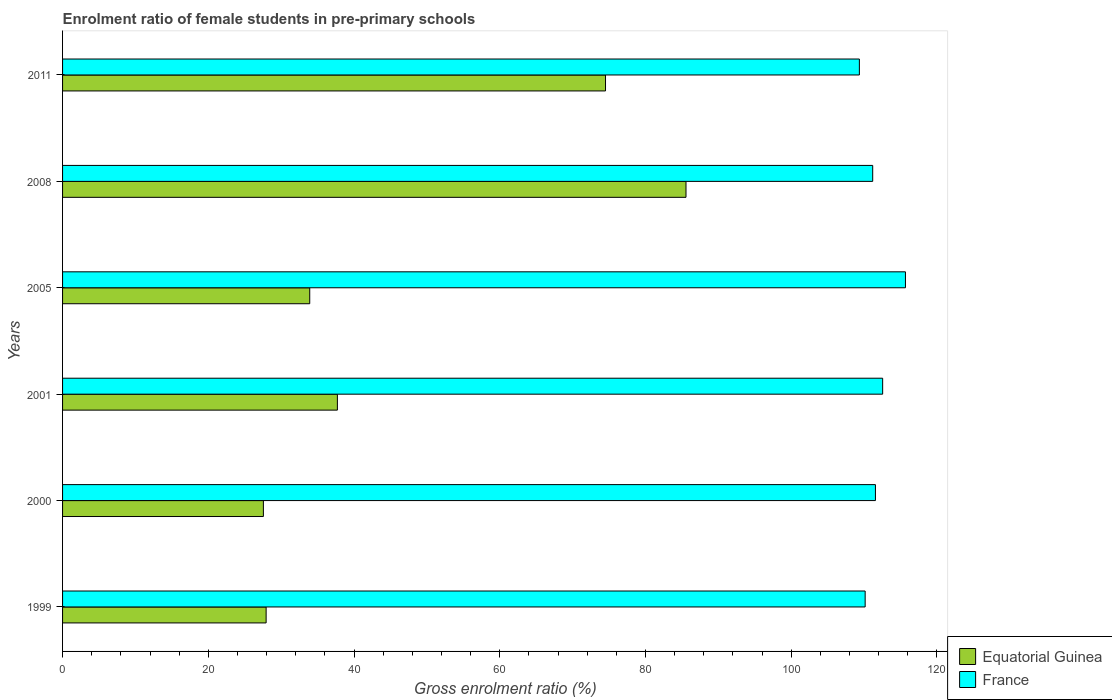Are the number of bars on each tick of the Y-axis equal?
Your answer should be very brief. Yes. How many bars are there on the 6th tick from the bottom?
Provide a succinct answer. 2. What is the label of the 2nd group of bars from the top?
Offer a very short reply. 2008. In how many cases, is the number of bars for a given year not equal to the number of legend labels?
Your answer should be very brief. 0. What is the enrolment ratio of female students in pre-primary schools in France in 2008?
Make the answer very short. 111.18. Across all years, what is the maximum enrolment ratio of female students in pre-primary schools in France?
Provide a succinct answer. 115.68. Across all years, what is the minimum enrolment ratio of female students in pre-primary schools in France?
Your answer should be very brief. 109.35. In which year was the enrolment ratio of female students in pre-primary schools in France maximum?
Provide a succinct answer. 2005. What is the total enrolment ratio of female students in pre-primary schools in Equatorial Guinea in the graph?
Your answer should be very brief. 287.21. What is the difference between the enrolment ratio of female students in pre-primary schools in Equatorial Guinea in 2000 and that in 2001?
Provide a short and direct response. -10.16. What is the difference between the enrolment ratio of female students in pre-primary schools in Equatorial Guinea in 2000 and the enrolment ratio of female students in pre-primary schools in France in 1999?
Give a very brief answer. -82.59. What is the average enrolment ratio of female students in pre-primary schools in Equatorial Guinea per year?
Make the answer very short. 47.87. In the year 2001, what is the difference between the enrolment ratio of female students in pre-primary schools in France and enrolment ratio of female students in pre-primary schools in Equatorial Guinea?
Give a very brief answer. 74.83. What is the ratio of the enrolment ratio of female students in pre-primary schools in Equatorial Guinea in 1999 to that in 2008?
Provide a succinct answer. 0.33. What is the difference between the highest and the second highest enrolment ratio of female students in pre-primary schools in France?
Your answer should be compact. 3.13. What is the difference between the highest and the lowest enrolment ratio of female students in pre-primary schools in France?
Your response must be concise. 6.32. In how many years, is the enrolment ratio of female students in pre-primary schools in France greater than the average enrolment ratio of female students in pre-primary schools in France taken over all years?
Provide a short and direct response. 2. Is the sum of the enrolment ratio of female students in pre-primary schools in Equatorial Guinea in 2000 and 2001 greater than the maximum enrolment ratio of female students in pre-primary schools in France across all years?
Your answer should be very brief. No. What does the 2nd bar from the top in 1999 represents?
Offer a very short reply. Equatorial Guinea. How many bars are there?
Make the answer very short. 12. How many years are there in the graph?
Offer a terse response. 6. How are the legend labels stacked?
Provide a short and direct response. Vertical. What is the title of the graph?
Ensure brevity in your answer.  Enrolment ratio of female students in pre-primary schools. Does "Italy" appear as one of the legend labels in the graph?
Keep it short and to the point. No. What is the label or title of the Y-axis?
Ensure brevity in your answer.  Years. What is the Gross enrolment ratio (%) in Equatorial Guinea in 1999?
Your response must be concise. 27.94. What is the Gross enrolment ratio (%) of France in 1999?
Your answer should be compact. 110.14. What is the Gross enrolment ratio (%) of Equatorial Guinea in 2000?
Your answer should be compact. 27.56. What is the Gross enrolment ratio (%) of France in 2000?
Provide a short and direct response. 111.56. What is the Gross enrolment ratio (%) of Equatorial Guinea in 2001?
Provide a short and direct response. 37.72. What is the Gross enrolment ratio (%) in France in 2001?
Your answer should be very brief. 112.55. What is the Gross enrolment ratio (%) of Equatorial Guinea in 2005?
Your answer should be very brief. 33.92. What is the Gross enrolment ratio (%) of France in 2005?
Offer a terse response. 115.68. What is the Gross enrolment ratio (%) of Equatorial Guinea in 2008?
Provide a succinct answer. 85.56. What is the Gross enrolment ratio (%) in France in 2008?
Provide a succinct answer. 111.18. What is the Gross enrolment ratio (%) of Equatorial Guinea in 2011?
Offer a very short reply. 74.51. What is the Gross enrolment ratio (%) in France in 2011?
Offer a terse response. 109.35. Across all years, what is the maximum Gross enrolment ratio (%) in Equatorial Guinea?
Provide a short and direct response. 85.56. Across all years, what is the maximum Gross enrolment ratio (%) of France?
Keep it short and to the point. 115.68. Across all years, what is the minimum Gross enrolment ratio (%) in Equatorial Guinea?
Give a very brief answer. 27.56. Across all years, what is the minimum Gross enrolment ratio (%) of France?
Provide a short and direct response. 109.35. What is the total Gross enrolment ratio (%) of Equatorial Guinea in the graph?
Make the answer very short. 287.21. What is the total Gross enrolment ratio (%) in France in the graph?
Make the answer very short. 670.46. What is the difference between the Gross enrolment ratio (%) of Equatorial Guinea in 1999 and that in 2000?
Your response must be concise. 0.38. What is the difference between the Gross enrolment ratio (%) in France in 1999 and that in 2000?
Offer a terse response. -1.41. What is the difference between the Gross enrolment ratio (%) in Equatorial Guinea in 1999 and that in 2001?
Provide a succinct answer. -9.78. What is the difference between the Gross enrolment ratio (%) of France in 1999 and that in 2001?
Provide a succinct answer. -2.4. What is the difference between the Gross enrolment ratio (%) in Equatorial Guinea in 1999 and that in 2005?
Your answer should be compact. -5.98. What is the difference between the Gross enrolment ratio (%) in France in 1999 and that in 2005?
Offer a terse response. -5.53. What is the difference between the Gross enrolment ratio (%) of Equatorial Guinea in 1999 and that in 2008?
Give a very brief answer. -57.62. What is the difference between the Gross enrolment ratio (%) of France in 1999 and that in 2008?
Offer a very short reply. -1.04. What is the difference between the Gross enrolment ratio (%) in Equatorial Guinea in 1999 and that in 2011?
Keep it short and to the point. -46.58. What is the difference between the Gross enrolment ratio (%) of France in 1999 and that in 2011?
Your answer should be compact. 0.79. What is the difference between the Gross enrolment ratio (%) in Equatorial Guinea in 2000 and that in 2001?
Your answer should be compact. -10.16. What is the difference between the Gross enrolment ratio (%) of France in 2000 and that in 2001?
Ensure brevity in your answer.  -0.99. What is the difference between the Gross enrolment ratio (%) of Equatorial Guinea in 2000 and that in 2005?
Your answer should be compact. -6.36. What is the difference between the Gross enrolment ratio (%) of France in 2000 and that in 2005?
Offer a terse response. -4.12. What is the difference between the Gross enrolment ratio (%) of Equatorial Guinea in 2000 and that in 2008?
Offer a terse response. -58. What is the difference between the Gross enrolment ratio (%) in France in 2000 and that in 2008?
Your answer should be compact. 0.38. What is the difference between the Gross enrolment ratio (%) in Equatorial Guinea in 2000 and that in 2011?
Offer a very short reply. -46.95. What is the difference between the Gross enrolment ratio (%) in France in 2000 and that in 2011?
Your response must be concise. 2.2. What is the difference between the Gross enrolment ratio (%) in Equatorial Guinea in 2001 and that in 2005?
Provide a short and direct response. 3.8. What is the difference between the Gross enrolment ratio (%) of France in 2001 and that in 2005?
Ensure brevity in your answer.  -3.13. What is the difference between the Gross enrolment ratio (%) of Equatorial Guinea in 2001 and that in 2008?
Your response must be concise. -47.84. What is the difference between the Gross enrolment ratio (%) of France in 2001 and that in 2008?
Provide a short and direct response. 1.36. What is the difference between the Gross enrolment ratio (%) of Equatorial Guinea in 2001 and that in 2011?
Your response must be concise. -36.8. What is the difference between the Gross enrolment ratio (%) in France in 2001 and that in 2011?
Offer a terse response. 3.19. What is the difference between the Gross enrolment ratio (%) in Equatorial Guinea in 2005 and that in 2008?
Provide a short and direct response. -51.64. What is the difference between the Gross enrolment ratio (%) of France in 2005 and that in 2008?
Your answer should be very brief. 4.49. What is the difference between the Gross enrolment ratio (%) in Equatorial Guinea in 2005 and that in 2011?
Provide a short and direct response. -40.59. What is the difference between the Gross enrolment ratio (%) in France in 2005 and that in 2011?
Your answer should be compact. 6.32. What is the difference between the Gross enrolment ratio (%) of Equatorial Guinea in 2008 and that in 2011?
Your answer should be compact. 11.05. What is the difference between the Gross enrolment ratio (%) in France in 2008 and that in 2011?
Make the answer very short. 1.83. What is the difference between the Gross enrolment ratio (%) in Equatorial Guinea in 1999 and the Gross enrolment ratio (%) in France in 2000?
Your answer should be compact. -83.62. What is the difference between the Gross enrolment ratio (%) of Equatorial Guinea in 1999 and the Gross enrolment ratio (%) of France in 2001?
Provide a short and direct response. -84.61. What is the difference between the Gross enrolment ratio (%) in Equatorial Guinea in 1999 and the Gross enrolment ratio (%) in France in 2005?
Offer a very short reply. -87.74. What is the difference between the Gross enrolment ratio (%) of Equatorial Guinea in 1999 and the Gross enrolment ratio (%) of France in 2008?
Your answer should be very brief. -83.25. What is the difference between the Gross enrolment ratio (%) of Equatorial Guinea in 1999 and the Gross enrolment ratio (%) of France in 2011?
Offer a terse response. -81.42. What is the difference between the Gross enrolment ratio (%) in Equatorial Guinea in 2000 and the Gross enrolment ratio (%) in France in 2001?
Your response must be concise. -84.99. What is the difference between the Gross enrolment ratio (%) of Equatorial Guinea in 2000 and the Gross enrolment ratio (%) of France in 2005?
Provide a succinct answer. -88.12. What is the difference between the Gross enrolment ratio (%) of Equatorial Guinea in 2000 and the Gross enrolment ratio (%) of France in 2008?
Your answer should be compact. -83.62. What is the difference between the Gross enrolment ratio (%) in Equatorial Guinea in 2000 and the Gross enrolment ratio (%) in France in 2011?
Keep it short and to the point. -81.79. What is the difference between the Gross enrolment ratio (%) of Equatorial Guinea in 2001 and the Gross enrolment ratio (%) of France in 2005?
Offer a very short reply. -77.96. What is the difference between the Gross enrolment ratio (%) of Equatorial Guinea in 2001 and the Gross enrolment ratio (%) of France in 2008?
Make the answer very short. -73.47. What is the difference between the Gross enrolment ratio (%) of Equatorial Guinea in 2001 and the Gross enrolment ratio (%) of France in 2011?
Give a very brief answer. -71.64. What is the difference between the Gross enrolment ratio (%) in Equatorial Guinea in 2005 and the Gross enrolment ratio (%) in France in 2008?
Ensure brevity in your answer.  -77.26. What is the difference between the Gross enrolment ratio (%) in Equatorial Guinea in 2005 and the Gross enrolment ratio (%) in France in 2011?
Your answer should be very brief. -75.43. What is the difference between the Gross enrolment ratio (%) of Equatorial Guinea in 2008 and the Gross enrolment ratio (%) of France in 2011?
Offer a very short reply. -23.79. What is the average Gross enrolment ratio (%) of Equatorial Guinea per year?
Offer a terse response. 47.87. What is the average Gross enrolment ratio (%) of France per year?
Your response must be concise. 111.74. In the year 1999, what is the difference between the Gross enrolment ratio (%) of Equatorial Guinea and Gross enrolment ratio (%) of France?
Keep it short and to the point. -82.21. In the year 2000, what is the difference between the Gross enrolment ratio (%) in Equatorial Guinea and Gross enrolment ratio (%) in France?
Keep it short and to the point. -84. In the year 2001, what is the difference between the Gross enrolment ratio (%) of Equatorial Guinea and Gross enrolment ratio (%) of France?
Your answer should be very brief. -74.83. In the year 2005, what is the difference between the Gross enrolment ratio (%) in Equatorial Guinea and Gross enrolment ratio (%) in France?
Ensure brevity in your answer.  -81.76. In the year 2008, what is the difference between the Gross enrolment ratio (%) in Equatorial Guinea and Gross enrolment ratio (%) in France?
Your answer should be very brief. -25.62. In the year 2011, what is the difference between the Gross enrolment ratio (%) in Equatorial Guinea and Gross enrolment ratio (%) in France?
Your answer should be very brief. -34.84. What is the ratio of the Gross enrolment ratio (%) of Equatorial Guinea in 1999 to that in 2000?
Offer a very short reply. 1.01. What is the ratio of the Gross enrolment ratio (%) of France in 1999 to that in 2000?
Give a very brief answer. 0.99. What is the ratio of the Gross enrolment ratio (%) of Equatorial Guinea in 1999 to that in 2001?
Provide a succinct answer. 0.74. What is the ratio of the Gross enrolment ratio (%) in France in 1999 to that in 2001?
Provide a succinct answer. 0.98. What is the ratio of the Gross enrolment ratio (%) of Equatorial Guinea in 1999 to that in 2005?
Ensure brevity in your answer.  0.82. What is the ratio of the Gross enrolment ratio (%) of France in 1999 to that in 2005?
Provide a short and direct response. 0.95. What is the ratio of the Gross enrolment ratio (%) in Equatorial Guinea in 1999 to that in 2008?
Offer a terse response. 0.33. What is the ratio of the Gross enrolment ratio (%) in Equatorial Guinea in 1999 to that in 2011?
Make the answer very short. 0.37. What is the ratio of the Gross enrolment ratio (%) of France in 1999 to that in 2011?
Make the answer very short. 1.01. What is the ratio of the Gross enrolment ratio (%) of Equatorial Guinea in 2000 to that in 2001?
Give a very brief answer. 0.73. What is the ratio of the Gross enrolment ratio (%) in Equatorial Guinea in 2000 to that in 2005?
Your answer should be compact. 0.81. What is the ratio of the Gross enrolment ratio (%) in France in 2000 to that in 2005?
Your response must be concise. 0.96. What is the ratio of the Gross enrolment ratio (%) of Equatorial Guinea in 2000 to that in 2008?
Offer a very short reply. 0.32. What is the ratio of the Gross enrolment ratio (%) in Equatorial Guinea in 2000 to that in 2011?
Ensure brevity in your answer.  0.37. What is the ratio of the Gross enrolment ratio (%) of France in 2000 to that in 2011?
Keep it short and to the point. 1.02. What is the ratio of the Gross enrolment ratio (%) in Equatorial Guinea in 2001 to that in 2005?
Give a very brief answer. 1.11. What is the ratio of the Gross enrolment ratio (%) of France in 2001 to that in 2005?
Provide a short and direct response. 0.97. What is the ratio of the Gross enrolment ratio (%) in Equatorial Guinea in 2001 to that in 2008?
Make the answer very short. 0.44. What is the ratio of the Gross enrolment ratio (%) of France in 2001 to that in 2008?
Your response must be concise. 1.01. What is the ratio of the Gross enrolment ratio (%) of Equatorial Guinea in 2001 to that in 2011?
Make the answer very short. 0.51. What is the ratio of the Gross enrolment ratio (%) in France in 2001 to that in 2011?
Your answer should be compact. 1.03. What is the ratio of the Gross enrolment ratio (%) of Equatorial Guinea in 2005 to that in 2008?
Offer a terse response. 0.4. What is the ratio of the Gross enrolment ratio (%) of France in 2005 to that in 2008?
Offer a very short reply. 1.04. What is the ratio of the Gross enrolment ratio (%) in Equatorial Guinea in 2005 to that in 2011?
Give a very brief answer. 0.46. What is the ratio of the Gross enrolment ratio (%) in France in 2005 to that in 2011?
Provide a succinct answer. 1.06. What is the ratio of the Gross enrolment ratio (%) in Equatorial Guinea in 2008 to that in 2011?
Offer a terse response. 1.15. What is the ratio of the Gross enrolment ratio (%) in France in 2008 to that in 2011?
Give a very brief answer. 1.02. What is the difference between the highest and the second highest Gross enrolment ratio (%) in Equatorial Guinea?
Ensure brevity in your answer.  11.05. What is the difference between the highest and the second highest Gross enrolment ratio (%) in France?
Offer a terse response. 3.13. What is the difference between the highest and the lowest Gross enrolment ratio (%) in Equatorial Guinea?
Your answer should be very brief. 58. What is the difference between the highest and the lowest Gross enrolment ratio (%) in France?
Your response must be concise. 6.32. 